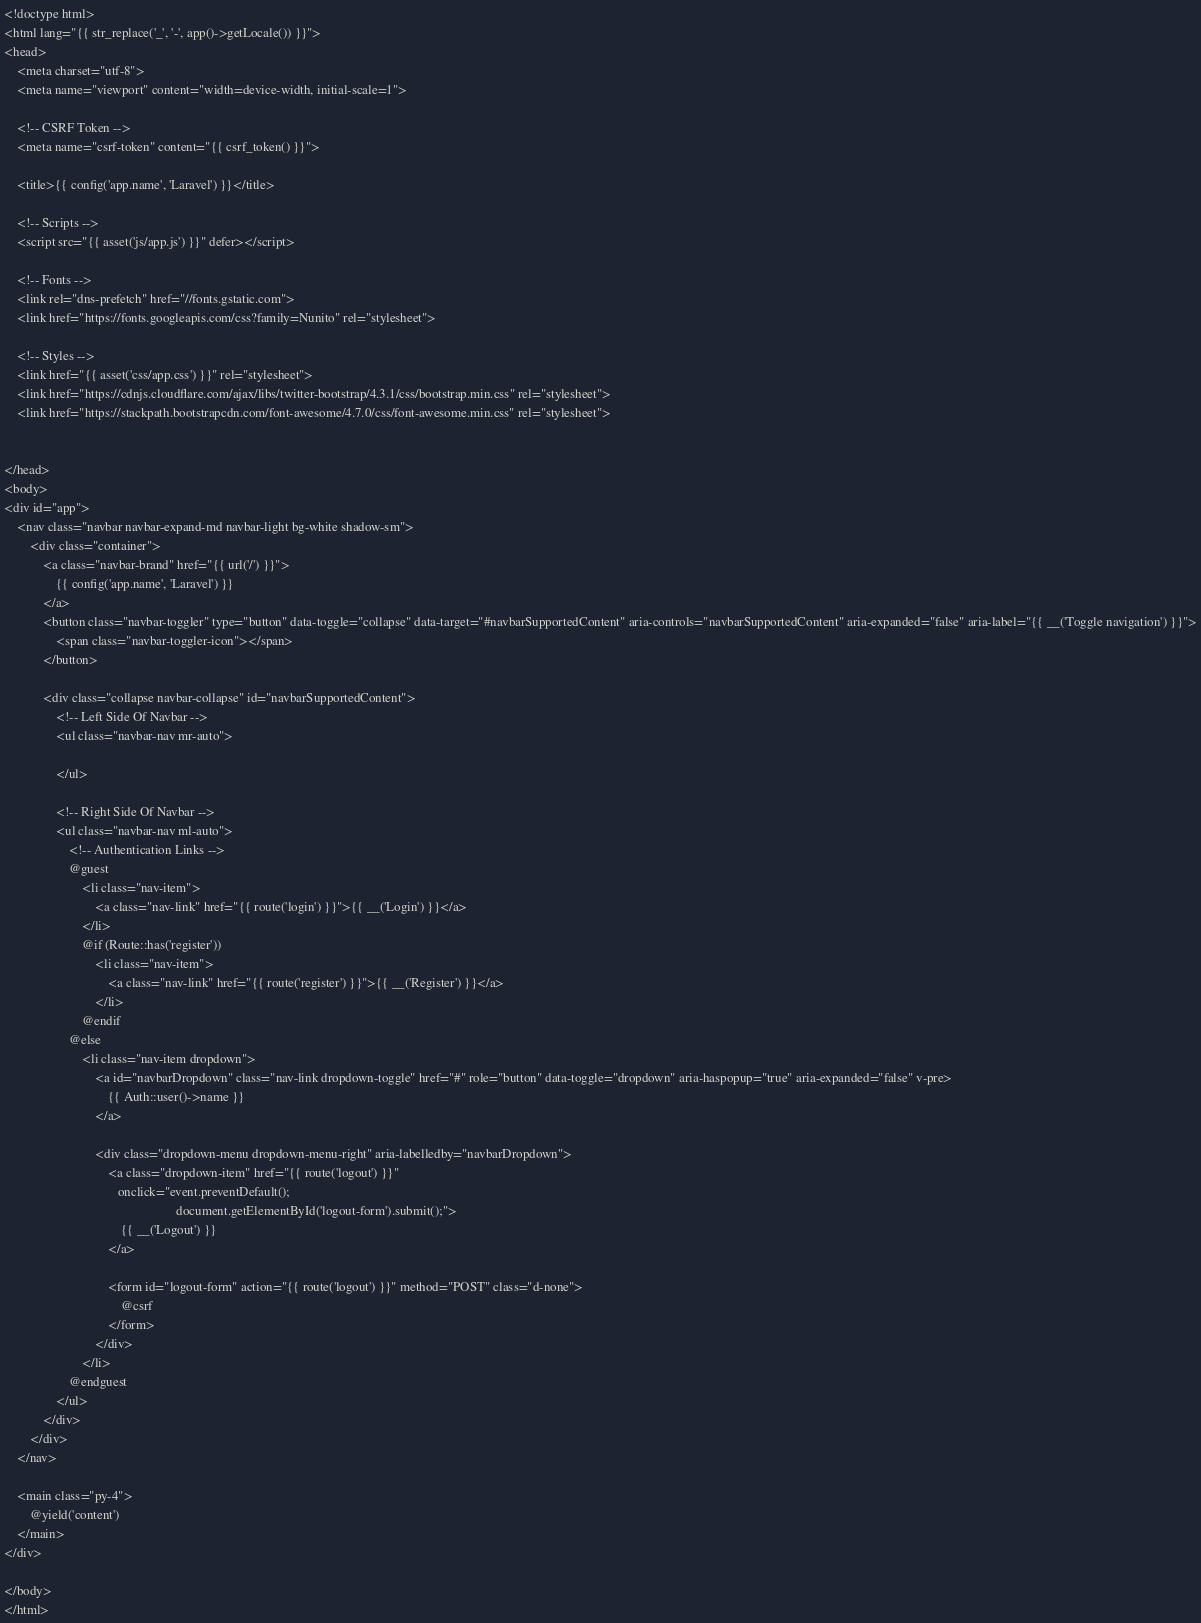<code> <loc_0><loc_0><loc_500><loc_500><_PHP_><!doctype html>
<html lang="{{ str_replace('_', '-', app()->getLocale()) }}">
<head>
    <meta charset="utf-8">
    <meta name="viewport" content="width=device-width, initial-scale=1">

    <!-- CSRF Token -->
    <meta name="csrf-token" content="{{ csrf_token() }}">

    <title>{{ config('app.name', 'Laravel') }}</title>

    <!-- Scripts -->
    <script src="{{ asset('js/app.js') }}" defer></script>

    <!-- Fonts -->
    <link rel="dns-prefetch" href="//fonts.gstatic.com">
    <link href="https://fonts.googleapis.com/css?family=Nunito" rel="stylesheet">

    <!-- Styles -->
    <link href="{{ asset('css/app.css') }}" rel="stylesheet">
    <link href="https://cdnjs.cloudflare.com/ajax/libs/twitter-bootstrap/4.3.1/css/bootstrap.min.css" rel="stylesheet">
    <link href="https://stackpath.bootstrapcdn.com/font-awesome/4.7.0/css/font-awesome.min.css" rel="stylesheet">


</head>
<body>
<div id="app">
    <nav class="navbar navbar-expand-md navbar-light bg-white shadow-sm">
        <div class="container">
            <a class="navbar-brand" href="{{ url('/') }}">
                {{ config('app.name', 'Laravel') }}
            </a>
            <button class="navbar-toggler" type="button" data-toggle="collapse" data-target="#navbarSupportedContent" aria-controls="navbarSupportedContent" aria-expanded="false" aria-label="{{ __('Toggle navigation') }}">
                <span class="navbar-toggler-icon"></span>
            </button>

            <div class="collapse navbar-collapse" id="navbarSupportedContent">
                <!-- Left Side Of Navbar -->
                <ul class="navbar-nav mr-auto">

                </ul>

                <!-- Right Side Of Navbar -->
                <ul class="navbar-nav ml-auto">
                    <!-- Authentication Links -->
                    @guest
                        <li class="nav-item">
                            <a class="nav-link" href="{{ route('login') }}">{{ __('Login') }}</a>
                        </li>
                        @if (Route::has('register'))
                            <li class="nav-item">
                                <a class="nav-link" href="{{ route('register') }}">{{ __('Register') }}</a>
                            </li>
                        @endif
                    @else
                        <li class="nav-item dropdown">
                            <a id="navbarDropdown" class="nav-link dropdown-toggle" href="#" role="button" data-toggle="dropdown" aria-haspopup="true" aria-expanded="false" v-pre>
                                {{ Auth::user()->name }}
                            </a>

                            <div class="dropdown-menu dropdown-menu-right" aria-labelledby="navbarDropdown">
                                <a class="dropdown-item" href="{{ route('logout') }}"
                                   onclick="event.preventDefault();
                                                     document.getElementById('logout-form').submit();">
                                    {{ __('Logout') }}
                                </a>

                                <form id="logout-form" action="{{ route('logout') }}" method="POST" class="d-none">
                                    @csrf
                                </form>
                            </div>
                        </li>
                    @endguest
                </ul>
            </div>
        </div>
    </nav>

    <main class="py-4">
        @yield('content')
    </main>
</div>

</body>
</html>
</code> 